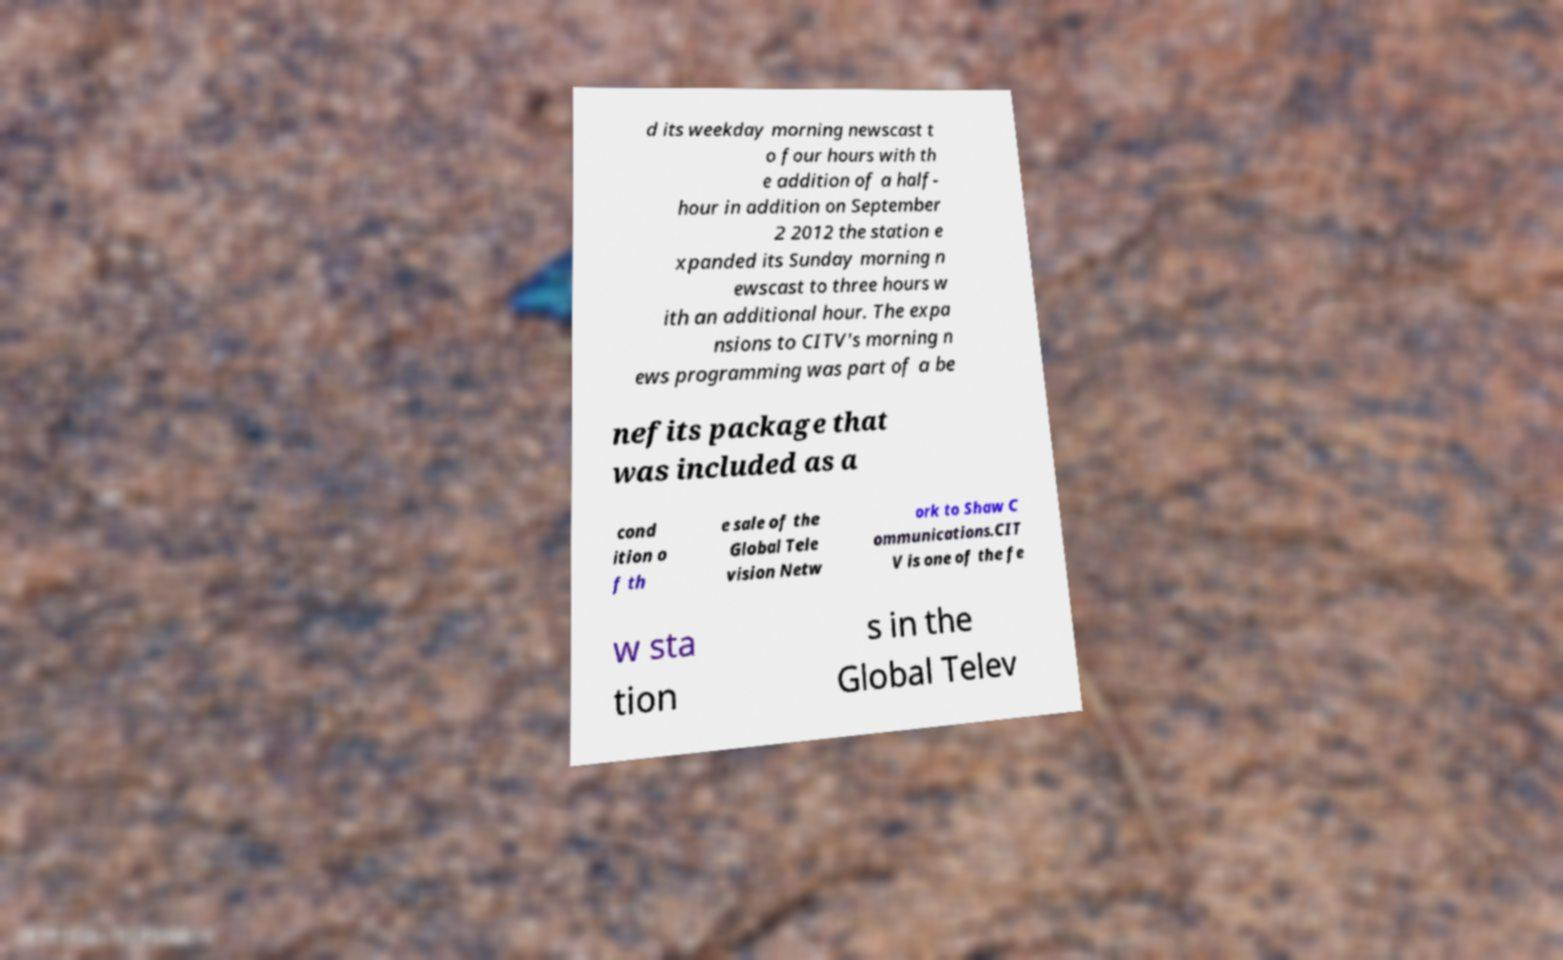For documentation purposes, I need the text within this image transcribed. Could you provide that? d its weekday morning newscast t o four hours with th e addition of a half- hour in addition on September 2 2012 the station e xpanded its Sunday morning n ewscast to three hours w ith an additional hour. The expa nsions to CITV's morning n ews programming was part of a be nefits package that was included as a cond ition o f th e sale of the Global Tele vision Netw ork to Shaw C ommunications.CIT V is one of the fe w sta tion s in the Global Telev 